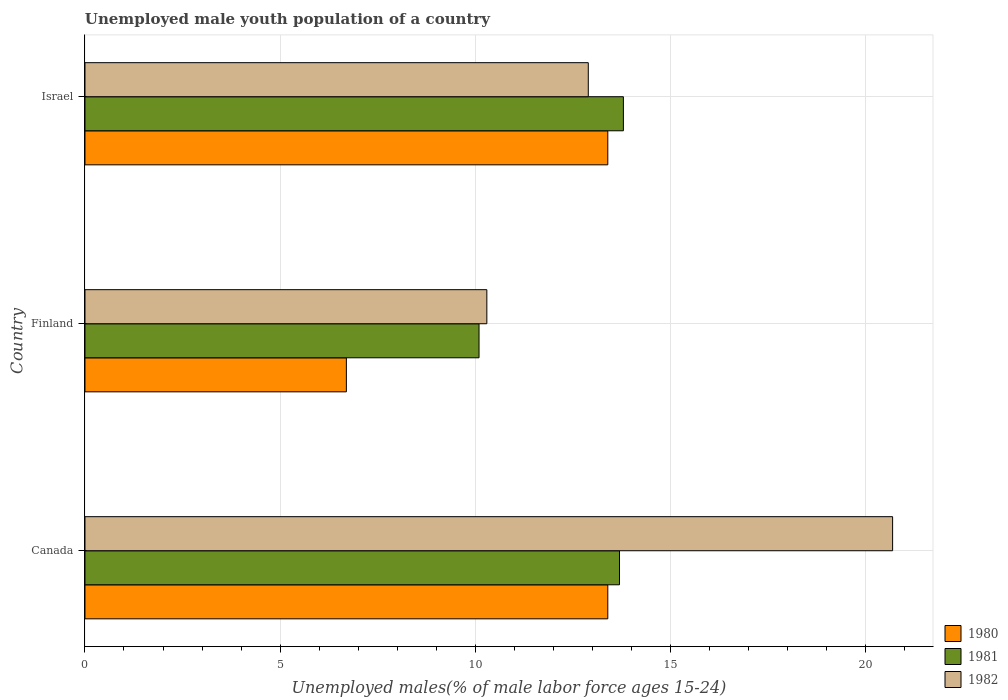How many different coloured bars are there?
Make the answer very short. 3. How many groups of bars are there?
Your response must be concise. 3. Are the number of bars on each tick of the Y-axis equal?
Ensure brevity in your answer.  Yes. What is the label of the 3rd group of bars from the top?
Give a very brief answer. Canada. What is the percentage of unemployed male youth population in 1981 in Israel?
Provide a short and direct response. 13.8. Across all countries, what is the maximum percentage of unemployed male youth population in 1980?
Keep it short and to the point. 13.4. Across all countries, what is the minimum percentage of unemployed male youth population in 1982?
Offer a very short reply. 10.3. In which country was the percentage of unemployed male youth population in 1980 maximum?
Provide a short and direct response. Canada. In which country was the percentage of unemployed male youth population in 1982 minimum?
Offer a very short reply. Finland. What is the total percentage of unemployed male youth population in 1982 in the graph?
Offer a very short reply. 43.9. What is the difference between the percentage of unemployed male youth population in 1982 in Canada and that in Finland?
Give a very brief answer. 10.4. What is the difference between the percentage of unemployed male youth population in 1980 in Canada and the percentage of unemployed male youth population in 1981 in Finland?
Give a very brief answer. 3.3. What is the average percentage of unemployed male youth population in 1981 per country?
Offer a very short reply. 12.53. What is the difference between the percentage of unemployed male youth population in 1982 and percentage of unemployed male youth population in 1981 in Canada?
Offer a terse response. 7. In how many countries, is the percentage of unemployed male youth population in 1981 greater than 2 %?
Provide a succinct answer. 3. What is the ratio of the percentage of unemployed male youth population in 1980 in Canada to that in Finland?
Your answer should be very brief. 2. What is the difference between the highest and the second highest percentage of unemployed male youth population in 1982?
Keep it short and to the point. 7.8. What is the difference between the highest and the lowest percentage of unemployed male youth population in 1982?
Offer a terse response. 10.4. Is it the case that in every country, the sum of the percentage of unemployed male youth population in 1981 and percentage of unemployed male youth population in 1980 is greater than the percentage of unemployed male youth population in 1982?
Your response must be concise. Yes. How many bars are there?
Your answer should be very brief. 9. How many countries are there in the graph?
Offer a very short reply. 3. What is the difference between two consecutive major ticks on the X-axis?
Offer a terse response. 5. Are the values on the major ticks of X-axis written in scientific E-notation?
Your answer should be compact. No. Does the graph contain grids?
Your answer should be compact. Yes. How many legend labels are there?
Make the answer very short. 3. What is the title of the graph?
Provide a short and direct response. Unemployed male youth population of a country. Does "2008" appear as one of the legend labels in the graph?
Give a very brief answer. No. What is the label or title of the X-axis?
Your response must be concise. Unemployed males(% of male labor force ages 15-24). What is the Unemployed males(% of male labor force ages 15-24) of 1980 in Canada?
Keep it short and to the point. 13.4. What is the Unemployed males(% of male labor force ages 15-24) of 1981 in Canada?
Provide a succinct answer. 13.7. What is the Unemployed males(% of male labor force ages 15-24) of 1982 in Canada?
Make the answer very short. 20.7. What is the Unemployed males(% of male labor force ages 15-24) in 1980 in Finland?
Make the answer very short. 6.7. What is the Unemployed males(% of male labor force ages 15-24) in 1981 in Finland?
Keep it short and to the point. 10.1. What is the Unemployed males(% of male labor force ages 15-24) of 1982 in Finland?
Your response must be concise. 10.3. What is the Unemployed males(% of male labor force ages 15-24) in 1980 in Israel?
Provide a short and direct response. 13.4. What is the Unemployed males(% of male labor force ages 15-24) in 1981 in Israel?
Offer a terse response. 13.8. What is the Unemployed males(% of male labor force ages 15-24) in 1982 in Israel?
Provide a succinct answer. 12.9. Across all countries, what is the maximum Unemployed males(% of male labor force ages 15-24) of 1980?
Keep it short and to the point. 13.4. Across all countries, what is the maximum Unemployed males(% of male labor force ages 15-24) in 1981?
Keep it short and to the point. 13.8. Across all countries, what is the maximum Unemployed males(% of male labor force ages 15-24) in 1982?
Provide a short and direct response. 20.7. Across all countries, what is the minimum Unemployed males(% of male labor force ages 15-24) in 1980?
Give a very brief answer. 6.7. Across all countries, what is the minimum Unemployed males(% of male labor force ages 15-24) of 1981?
Your response must be concise. 10.1. Across all countries, what is the minimum Unemployed males(% of male labor force ages 15-24) of 1982?
Provide a short and direct response. 10.3. What is the total Unemployed males(% of male labor force ages 15-24) of 1980 in the graph?
Make the answer very short. 33.5. What is the total Unemployed males(% of male labor force ages 15-24) of 1981 in the graph?
Offer a terse response. 37.6. What is the total Unemployed males(% of male labor force ages 15-24) of 1982 in the graph?
Make the answer very short. 43.9. What is the difference between the Unemployed males(% of male labor force ages 15-24) of 1981 in Canada and that in Israel?
Your response must be concise. -0.1. What is the difference between the Unemployed males(% of male labor force ages 15-24) of 1982 in Canada and that in Israel?
Provide a short and direct response. 7.8. What is the difference between the Unemployed males(% of male labor force ages 15-24) in 1980 in Finland and that in Israel?
Give a very brief answer. -6.7. What is the difference between the Unemployed males(% of male labor force ages 15-24) in 1980 in Canada and the Unemployed males(% of male labor force ages 15-24) in 1981 in Finland?
Make the answer very short. 3.3. What is the difference between the Unemployed males(% of male labor force ages 15-24) of 1980 in Finland and the Unemployed males(% of male labor force ages 15-24) of 1981 in Israel?
Your answer should be compact. -7.1. What is the difference between the Unemployed males(% of male labor force ages 15-24) of 1981 in Finland and the Unemployed males(% of male labor force ages 15-24) of 1982 in Israel?
Keep it short and to the point. -2.8. What is the average Unemployed males(% of male labor force ages 15-24) in 1980 per country?
Your answer should be very brief. 11.17. What is the average Unemployed males(% of male labor force ages 15-24) of 1981 per country?
Keep it short and to the point. 12.53. What is the average Unemployed males(% of male labor force ages 15-24) of 1982 per country?
Your answer should be very brief. 14.63. What is the difference between the Unemployed males(% of male labor force ages 15-24) of 1980 and Unemployed males(% of male labor force ages 15-24) of 1981 in Canada?
Give a very brief answer. -0.3. What is the difference between the Unemployed males(% of male labor force ages 15-24) of 1980 and Unemployed males(% of male labor force ages 15-24) of 1982 in Canada?
Keep it short and to the point. -7.3. What is the difference between the Unemployed males(% of male labor force ages 15-24) of 1980 and Unemployed males(% of male labor force ages 15-24) of 1981 in Finland?
Your answer should be compact. -3.4. What is the difference between the Unemployed males(% of male labor force ages 15-24) in 1980 and Unemployed males(% of male labor force ages 15-24) in 1981 in Israel?
Ensure brevity in your answer.  -0.4. What is the ratio of the Unemployed males(% of male labor force ages 15-24) in 1981 in Canada to that in Finland?
Give a very brief answer. 1.36. What is the ratio of the Unemployed males(% of male labor force ages 15-24) in 1982 in Canada to that in Finland?
Provide a short and direct response. 2.01. What is the ratio of the Unemployed males(% of male labor force ages 15-24) in 1981 in Canada to that in Israel?
Ensure brevity in your answer.  0.99. What is the ratio of the Unemployed males(% of male labor force ages 15-24) of 1982 in Canada to that in Israel?
Provide a short and direct response. 1.6. What is the ratio of the Unemployed males(% of male labor force ages 15-24) in 1981 in Finland to that in Israel?
Keep it short and to the point. 0.73. What is the ratio of the Unemployed males(% of male labor force ages 15-24) in 1982 in Finland to that in Israel?
Offer a very short reply. 0.8. What is the difference between the highest and the second highest Unemployed males(% of male labor force ages 15-24) of 1980?
Give a very brief answer. 0. What is the difference between the highest and the second highest Unemployed males(% of male labor force ages 15-24) of 1981?
Ensure brevity in your answer.  0.1. What is the difference between the highest and the second highest Unemployed males(% of male labor force ages 15-24) in 1982?
Ensure brevity in your answer.  7.8. 